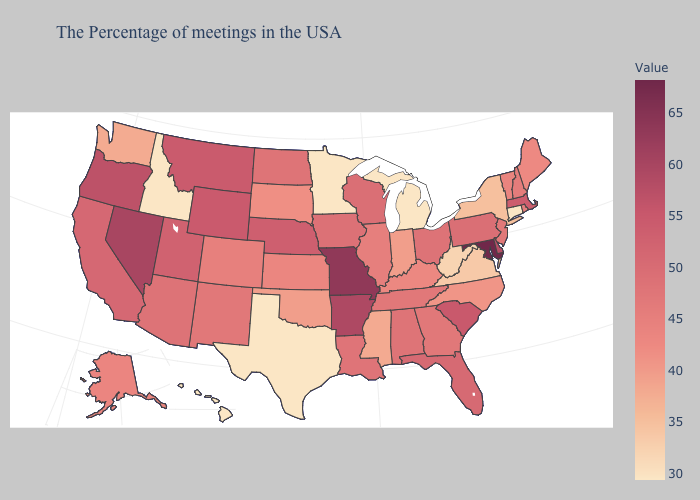Which states have the highest value in the USA?
Keep it brief. Maryland. Among the states that border Minnesota , which have the lowest value?
Be succinct. South Dakota. Among the states that border Missouri , does Tennessee have the lowest value?
Keep it brief. No. Among the states that border Arizona , which have the highest value?
Give a very brief answer. Nevada. Which states have the lowest value in the USA?
Concise answer only. Connecticut, Michigan, Minnesota, Texas, Idaho, Hawaii. Does New Jersey have the lowest value in the USA?
Concise answer only. No. Which states have the lowest value in the USA?
Write a very short answer. Connecticut, Michigan, Minnesota, Texas, Idaho, Hawaii. 